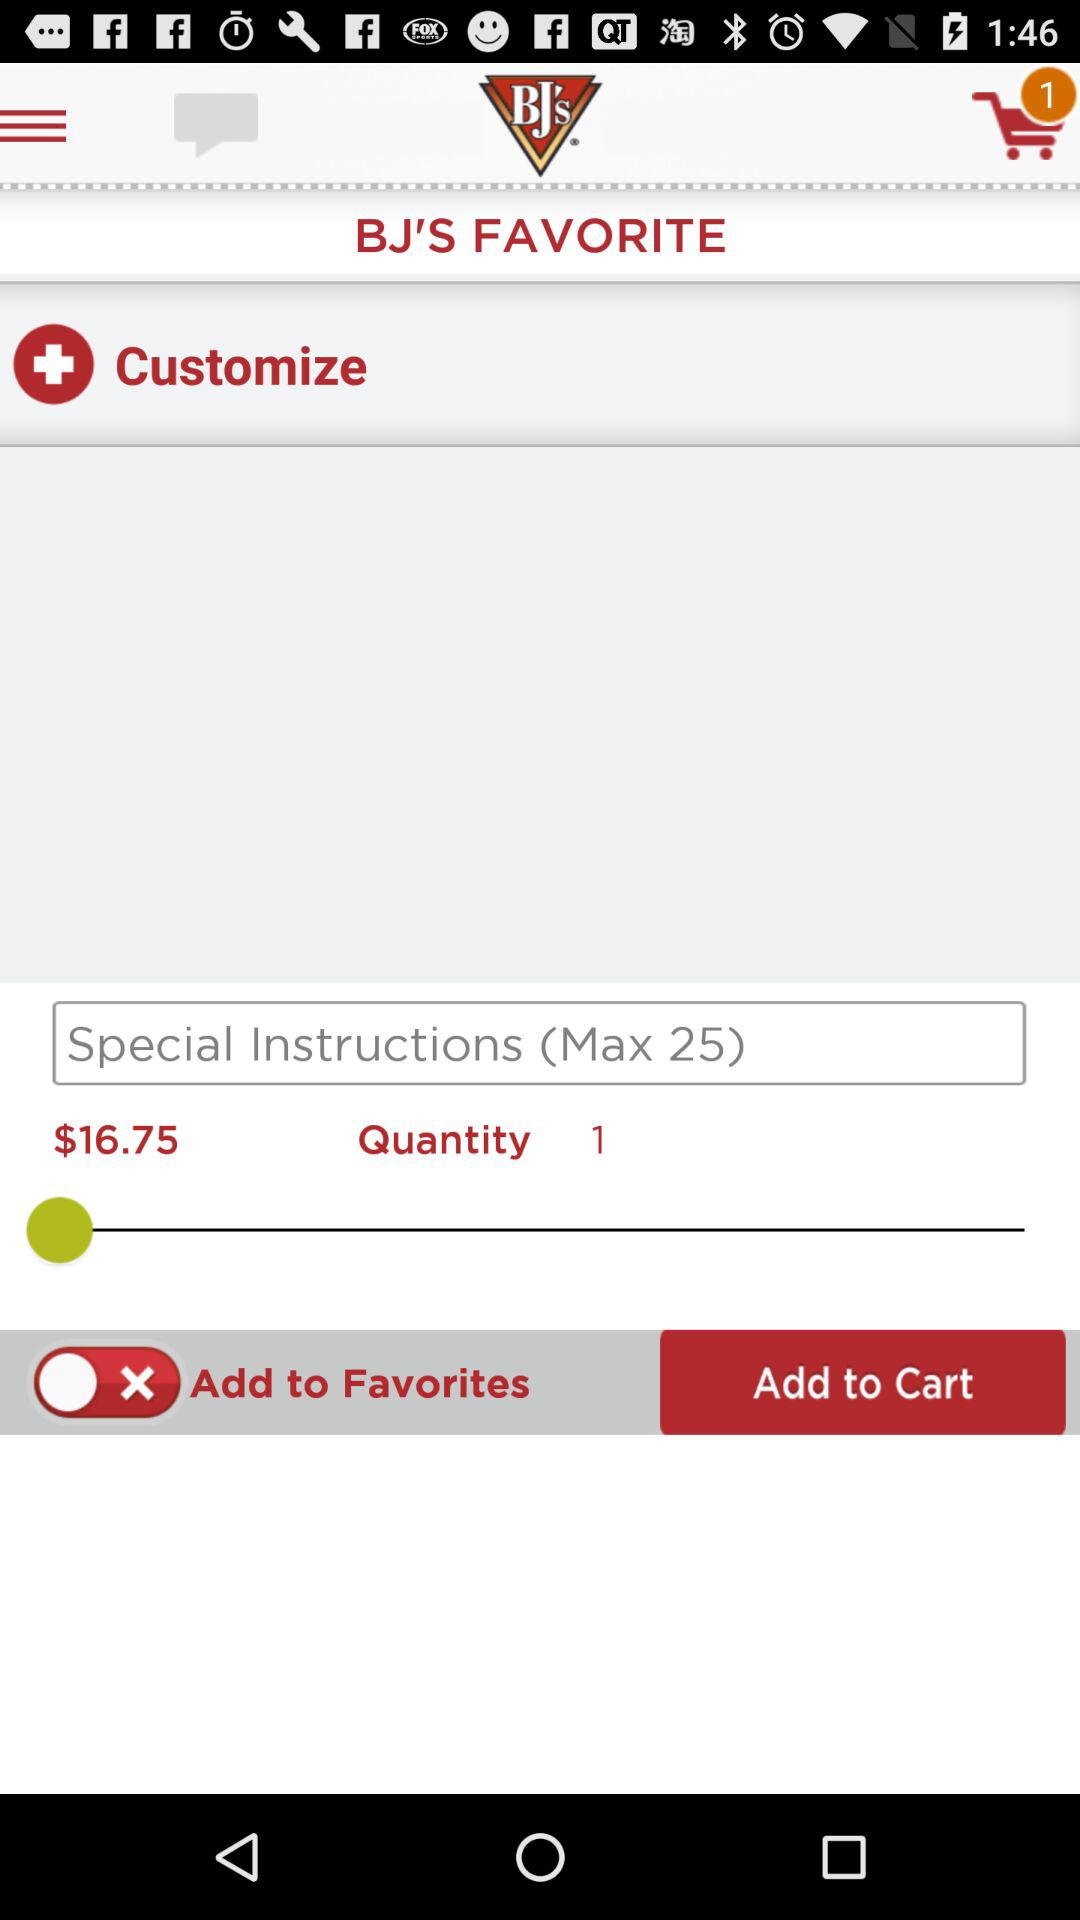What is the maximum length of the special instructions? The maximum length of the special instructions is 25. 